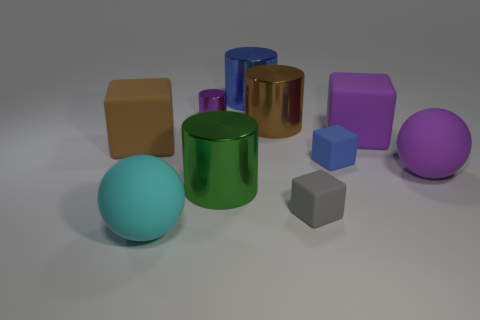Can you describe the colors and shapes of the objects in detail? Certainly! We have a variety of objects with distinct colors and shapes. Starting from the left, there is a pale blue sphere and a green cylinder. To the right of the green cylinder is a tiny purple cylinder and a larger gold-colored cylinder. There's a brown cube and a violet hexagonal prism, followed by a small light blue cube and a large purple sphere. The shapes include cylinders, cubes, a sphere, and a hexagonal prism, while the color palette ranges from metallic gold to various matte hues. 